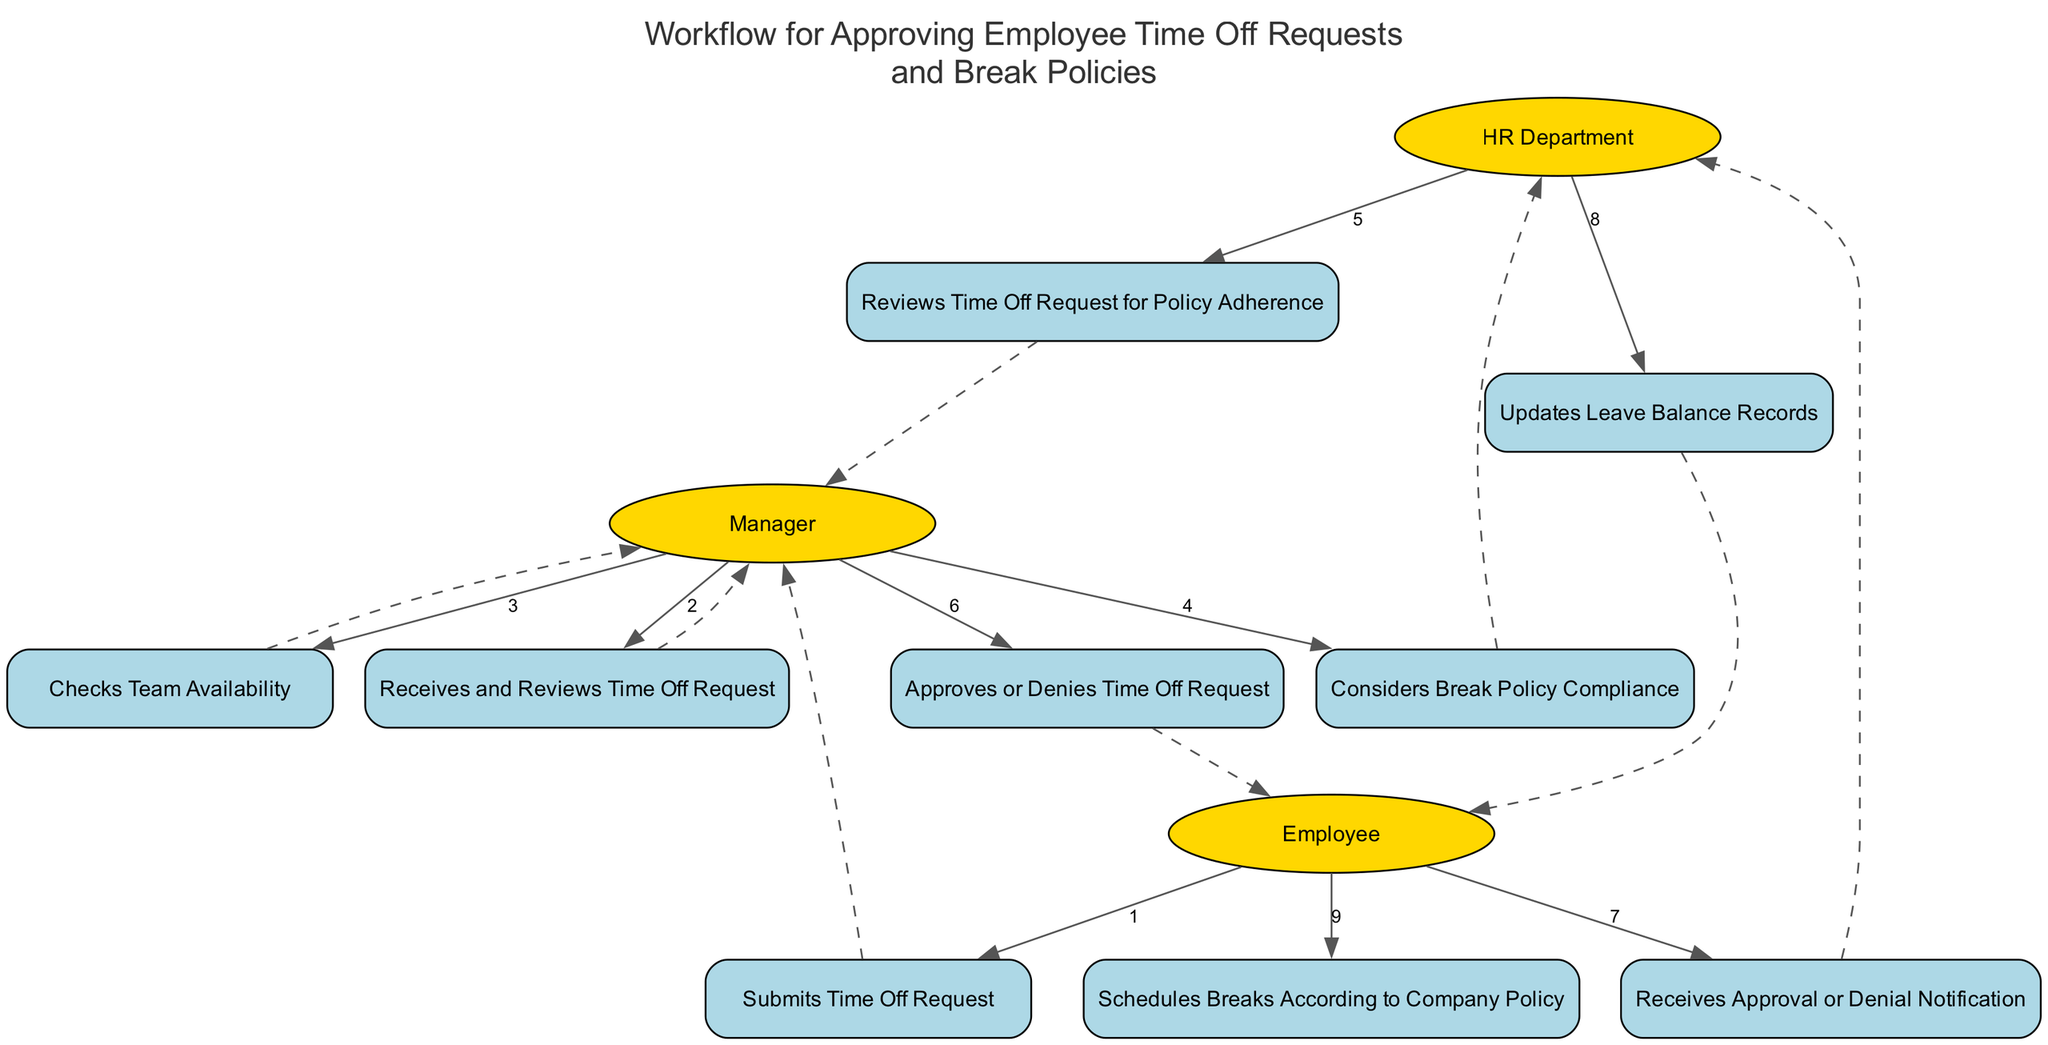What is the first action performed in the workflow? The diagram indicates that the first action is initiated by the Employee who "Submits Time Off Request." This is the starting point of the sequence, as it is the first labeled action in the list.
Answer: Submits Time Off Request How many actors are involved in the workflow? The diagram lists three distinct actors: Employee, Manager, and HR Department. Counting these gives a total of three actors involved in the process.
Answer: Three What action follows the "Receives Approval or Denial Notification"? According to the sequence flow in the diagram, after the Employee receives the "Approval or Denial Notification", the next action is for the Employee to "Schedules Breaks According to Company Policy". This indicates what the employee will do following the notification.
Answer: Schedules Breaks According to Company Policy How many total actions are there in the workflow? By counting each action stated in the diagram, we find a total of nine actions, as each distinct action related to the actors is outlined.
Answer: Nine What is the last action performed in the workflow? The last action listed in the workflow is "Schedules Breaks According to Company Policy". Therefore, this action represents the conclusion of the workflow, following all previous steps.
Answer: Schedules Breaks According to Company Policy Which actor reviews the Time Off Request for Policy Adherence? The HR Department is specifically indicated in the sequence diagram as responsible for reviewing the Time Off Request, ensuring it complies with established policies.
Answer: HR Department Which action involves the Manager determining compliance with the break policy? The action where the Manager "Considers Break Policy Compliance" explicitly indicates the assessment of break policies as one of the Manager's responsibilities in the workflow.
Answer: Considers Break Policy Compliance What is the purpose of the dashed edges in the diagram? The dashed edges in the sequence diagrams typically represent a transition or relationship between actions, indicating that there is some form of dependency or flow from one action to another in the process.
Answer: Indicate flow What step follows after the Manager checks Team Availability? After the Manager checks Team Availability, the next step is for the Manager to "Considers Break Policy Compliance". This sequential progression means both actions are part of the decision-making process before approving the time off request.
Answer: Considers Break Policy Compliance 